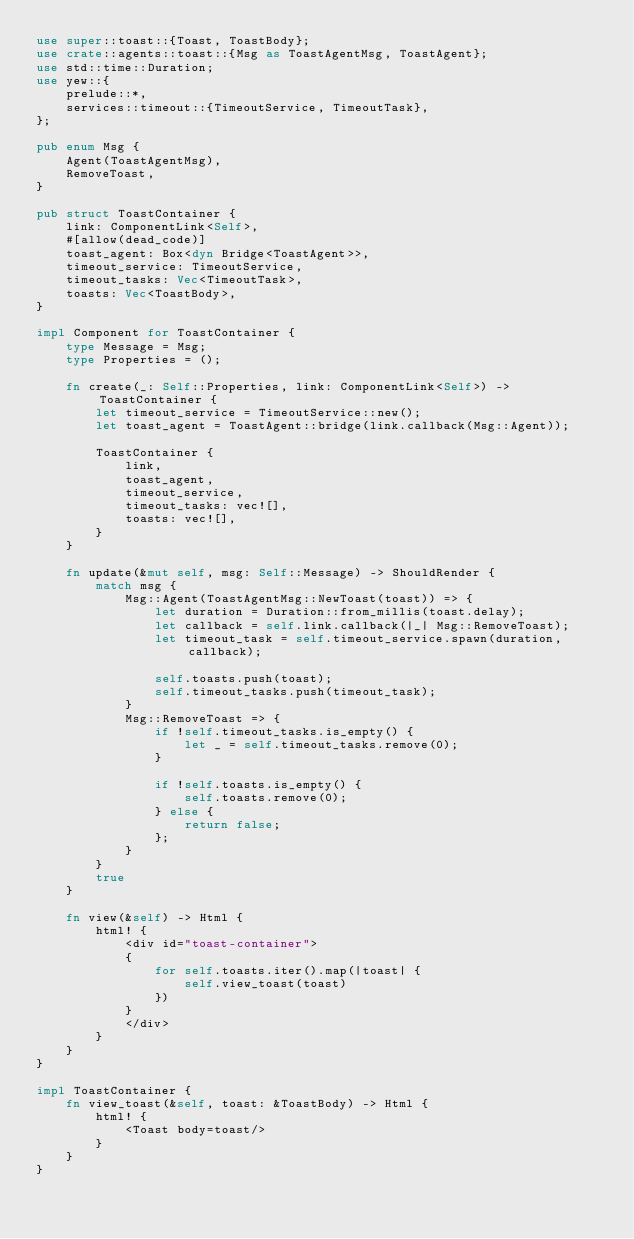Convert code to text. <code><loc_0><loc_0><loc_500><loc_500><_Rust_>use super::toast::{Toast, ToastBody};
use crate::agents::toast::{Msg as ToastAgentMsg, ToastAgent};
use std::time::Duration;
use yew::{
    prelude::*,
    services::timeout::{TimeoutService, TimeoutTask},
};

pub enum Msg {
    Agent(ToastAgentMsg),
    RemoveToast,
}

pub struct ToastContainer {
    link: ComponentLink<Self>,
    #[allow(dead_code)]
    toast_agent: Box<dyn Bridge<ToastAgent>>,
    timeout_service: TimeoutService,
    timeout_tasks: Vec<TimeoutTask>,
    toasts: Vec<ToastBody>,
}

impl Component for ToastContainer {
    type Message = Msg;
    type Properties = ();

    fn create(_: Self::Properties, link: ComponentLink<Self>) -> ToastContainer {
        let timeout_service = TimeoutService::new();
        let toast_agent = ToastAgent::bridge(link.callback(Msg::Agent));

        ToastContainer {
            link,
            toast_agent,
            timeout_service,
            timeout_tasks: vec![],
            toasts: vec![],
        }
    }

    fn update(&mut self, msg: Self::Message) -> ShouldRender {
        match msg {
            Msg::Agent(ToastAgentMsg::NewToast(toast)) => {
                let duration = Duration::from_millis(toast.delay);
                let callback = self.link.callback(|_| Msg::RemoveToast);
                let timeout_task = self.timeout_service.spawn(duration, callback);

                self.toasts.push(toast);
                self.timeout_tasks.push(timeout_task);
            }
            Msg::RemoveToast => {
                if !self.timeout_tasks.is_empty() {
                    let _ = self.timeout_tasks.remove(0);
                }

                if !self.toasts.is_empty() {
                    self.toasts.remove(0);
                } else {
                    return false;
                };
            }
        }
        true
    }

    fn view(&self) -> Html {
        html! {
            <div id="toast-container">
            {
                for self.toasts.iter().map(|toast| {
                    self.view_toast(toast)
                })
            }
            </div>
        }
    }
}

impl ToastContainer {
    fn view_toast(&self, toast: &ToastBody) -> Html {
        html! {
            <Toast body=toast/>
        }
    }
}
</code> 